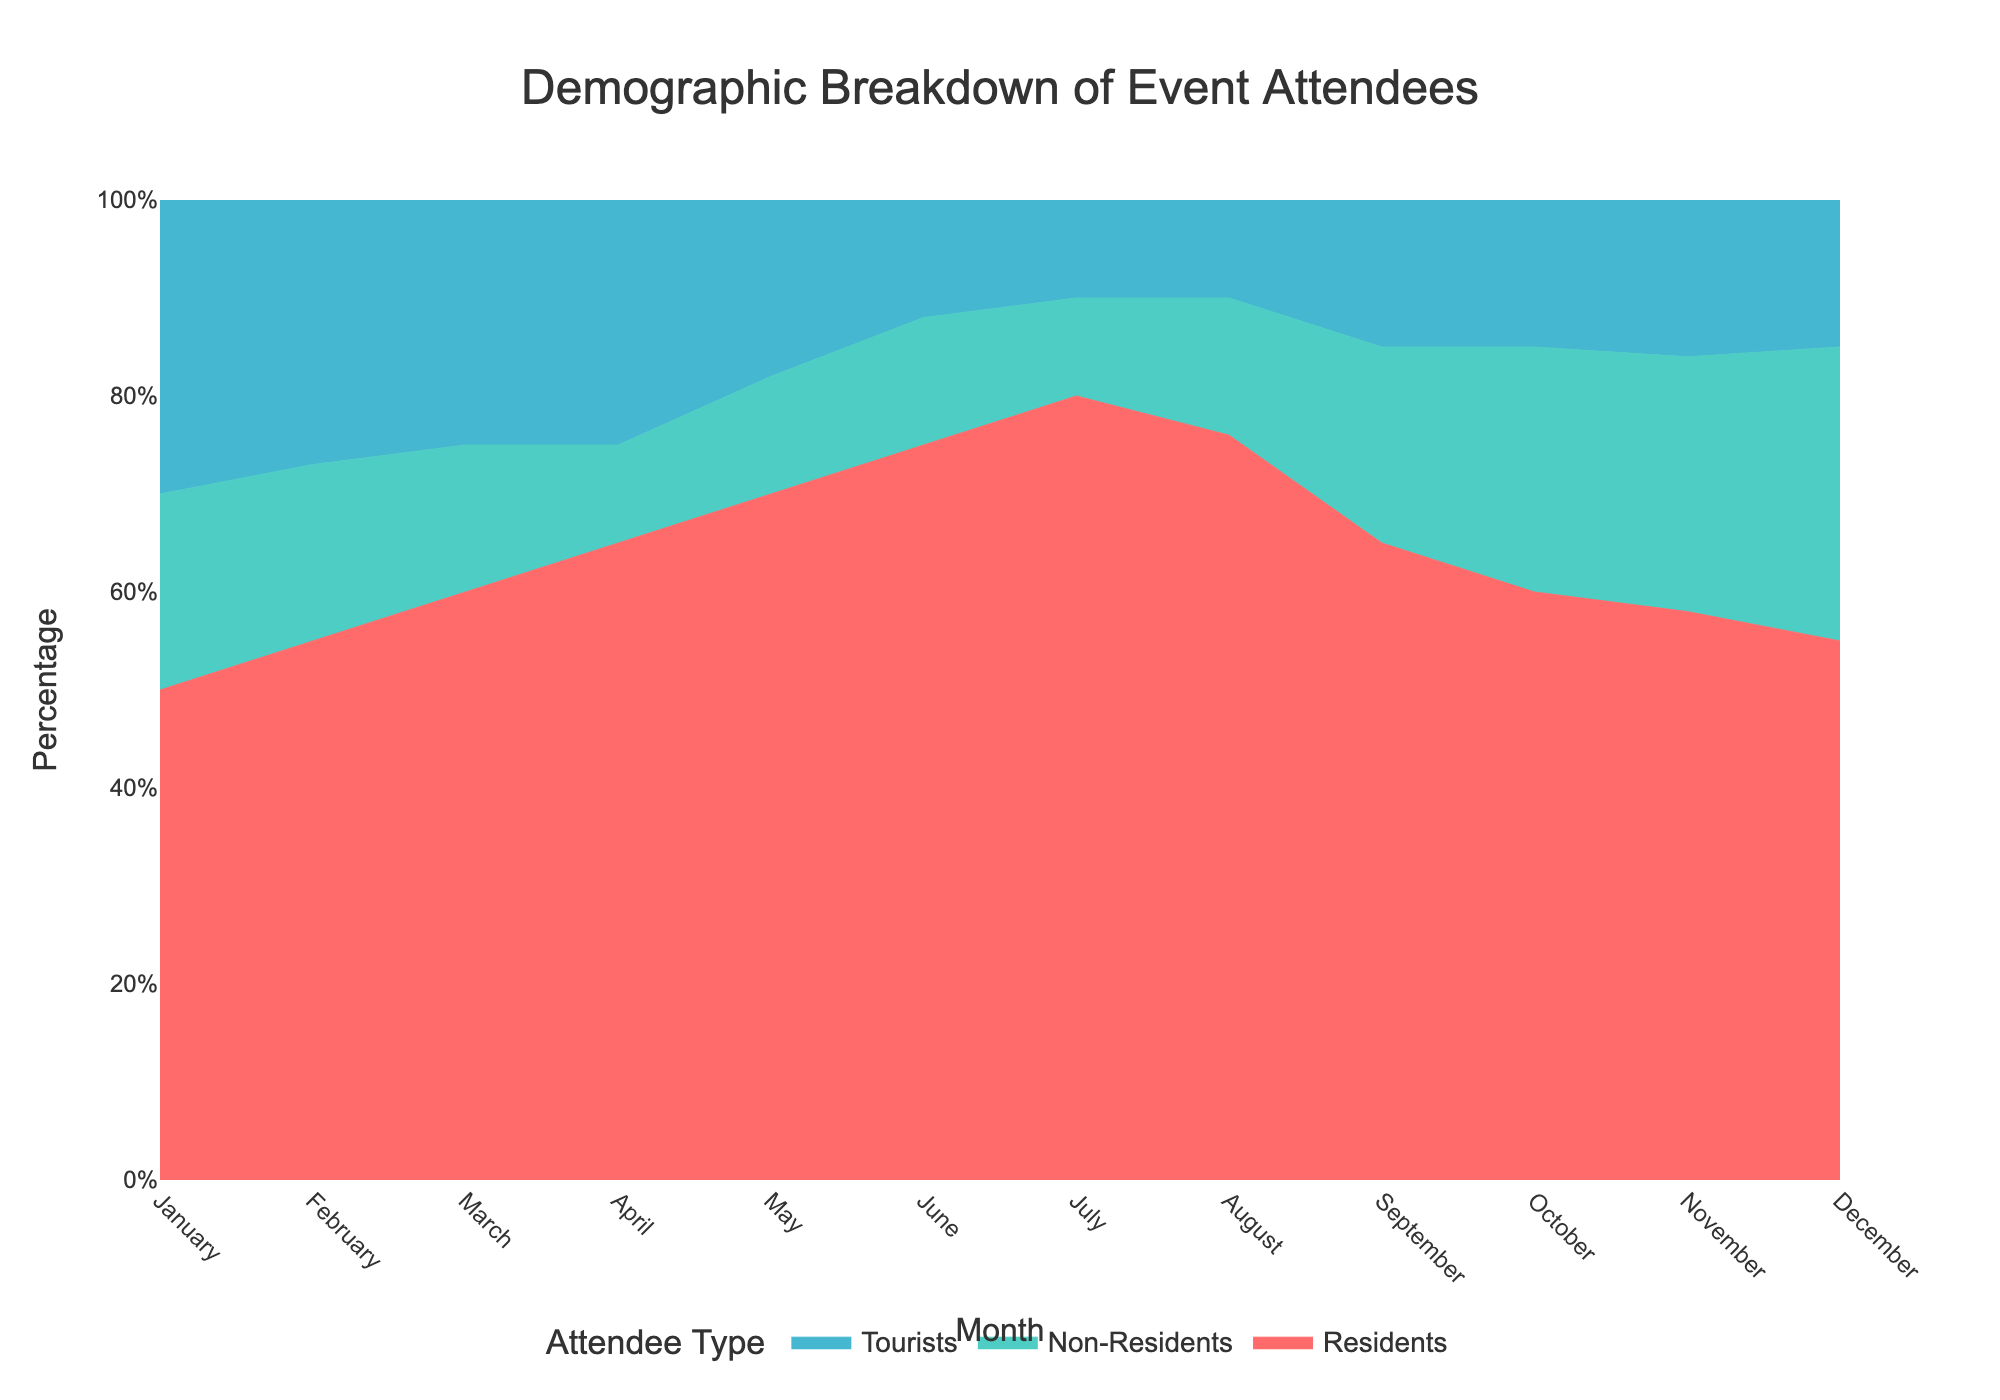What is the title of the chart? The title is typically located at the top of the chart and is clearly labeled. By looking at the figure, you can read the title directly.
Answer: Demographic Breakdown of Event Attendees Which month had the highest percentage of residents attending the events? The figure shows lines for each demographic, stacked to 100%. The highest point for residents can be visually identified by observing the top of the residents' area filling the chart.
Answer: July In which month did tourists have the lowest percentage of attendance? Look at the lowest points of the area colored for tourists. Identify the month that corresponds to the smallest portion of the chart section representing tourists.
Answer: July and August How does the percentage of non-residents change from January to December? Observe the non-residents' area from January to December. Trace their area to understand how their percentage increased or decreased throughout the year. Note specific increases or decreases.
Answer: Increased from January to December What trend can you observe for the percentage of residents over the months? Look at the overall shape of the residents' area from January to December. Identify if it generally increases, decreases, or remains stable.
Answer: Generally increases What is the approximate percentage of tourists in February? Locate February on the x-axis, then look at the height of the tourists' section to approximate its percentage.
Answer: Approximately 27% Which demographic has the most stable attendance percentage throughout the year? Compare the three areas for fluctuations. The more horizontal and stable the section, the more consistent the attendance.
Answer: Tourists How does the percentage of residents in May compare to November? Identify the heights of the residents' area for both May and November. Compare the two values to see the difference.
Answer: Higher in May than in November In which months do non-residents and tourists have approximately equal attendance percentages? Look for points where the non-residents’ and tourists’ areas are roughly similar in height.
Answer: April Does any month have a perfectly even distribution among all three demographics? Check for any month where the heights of all three sections are equal, representing an even split of 33.3% each.
Answer: No 